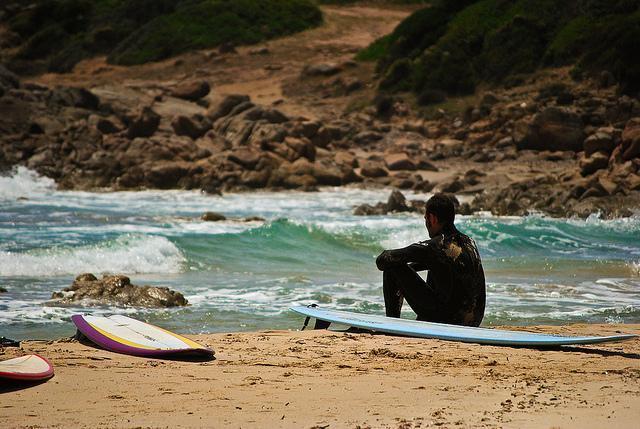How many surfboards are there?
Give a very brief answer. 2. How many woman are holding a donut with one hand?
Give a very brief answer. 0. 